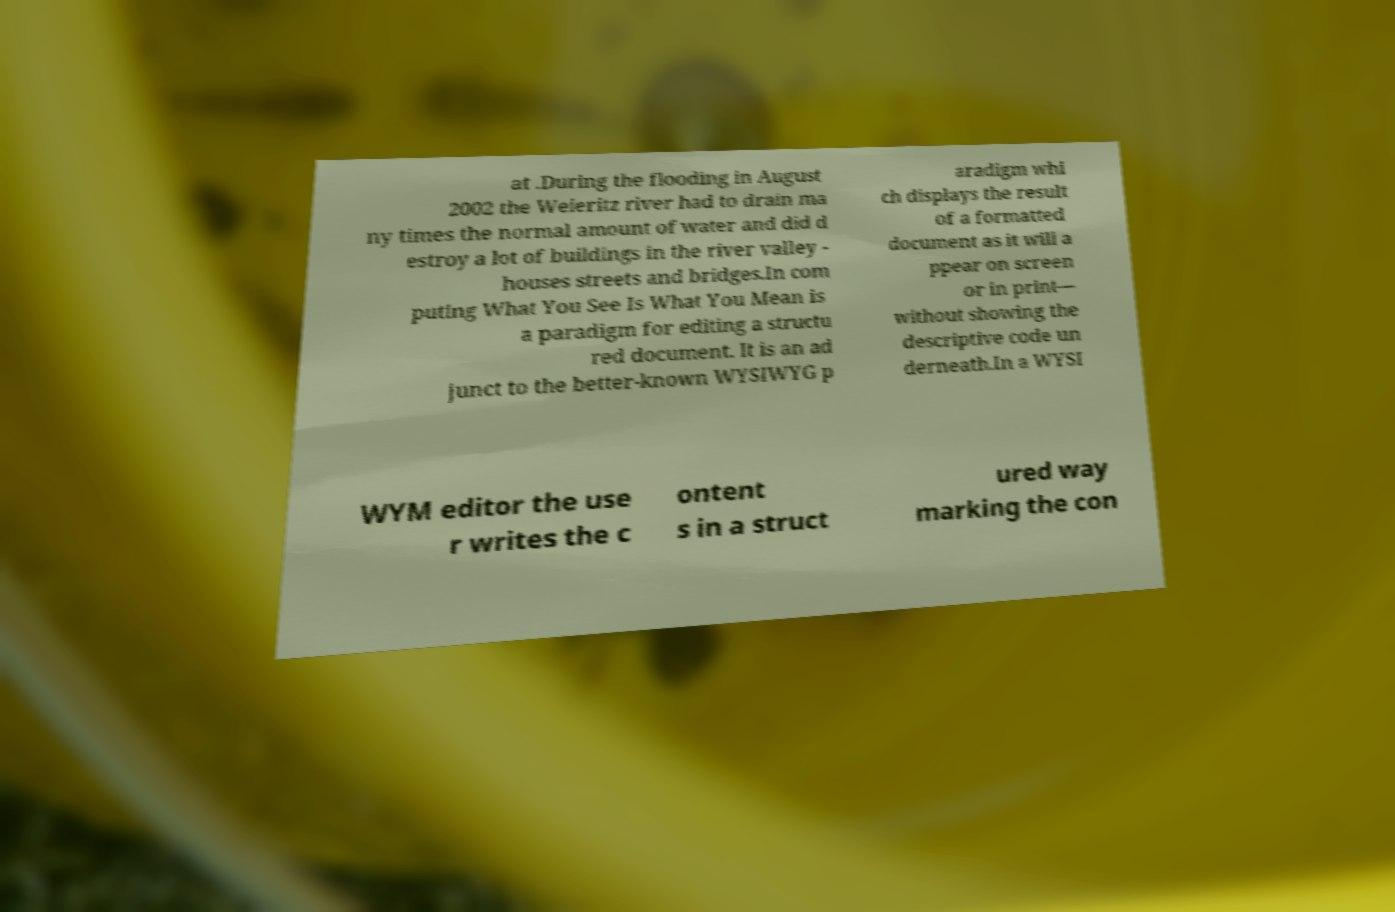What messages or text are displayed in this image? I need them in a readable, typed format. at .During the flooding in August 2002 the Weieritz river had to drain ma ny times the normal amount of water and did d estroy a lot of buildings in the river valley - houses streets and bridges.In com puting What You See Is What You Mean is a paradigm for editing a structu red document. It is an ad junct to the better-known WYSIWYG p aradigm whi ch displays the result of a formatted document as it will a ppear on screen or in print— without showing the descriptive code un derneath.In a WYSI WYM editor the use r writes the c ontent s in a struct ured way marking the con 